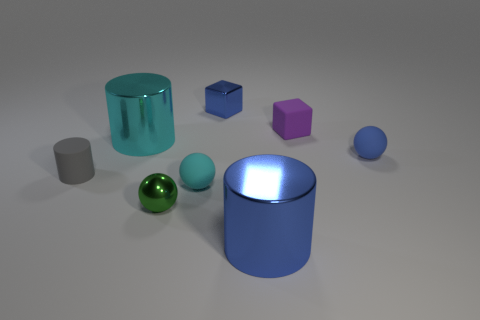Does the matte block have the same color as the tiny metal sphere?
Keep it short and to the point. No. What shape is the blue shiny object that is in front of the blue metal cube?
Offer a very short reply. Cylinder. Is the color of the small metallic object that is in front of the blue rubber thing the same as the tiny shiny cube?
Your response must be concise. No. How many small metal things have the same color as the tiny matte cylinder?
Provide a succinct answer. 0. What number of tiny yellow rubber things are there?
Provide a short and direct response. 0. What number of other cyan spheres have the same material as the small cyan ball?
Your response must be concise. 0. The blue object that is the same shape as the large cyan shiny thing is what size?
Provide a succinct answer. Large. What is the tiny green sphere made of?
Provide a succinct answer. Metal. What is the material of the small cube right of the blue shiny object that is in front of the small ball in front of the cyan matte thing?
Give a very brief answer. Rubber. Is there anything else that has the same shape as the small green object?
Provide a succinct answer. Yes. 